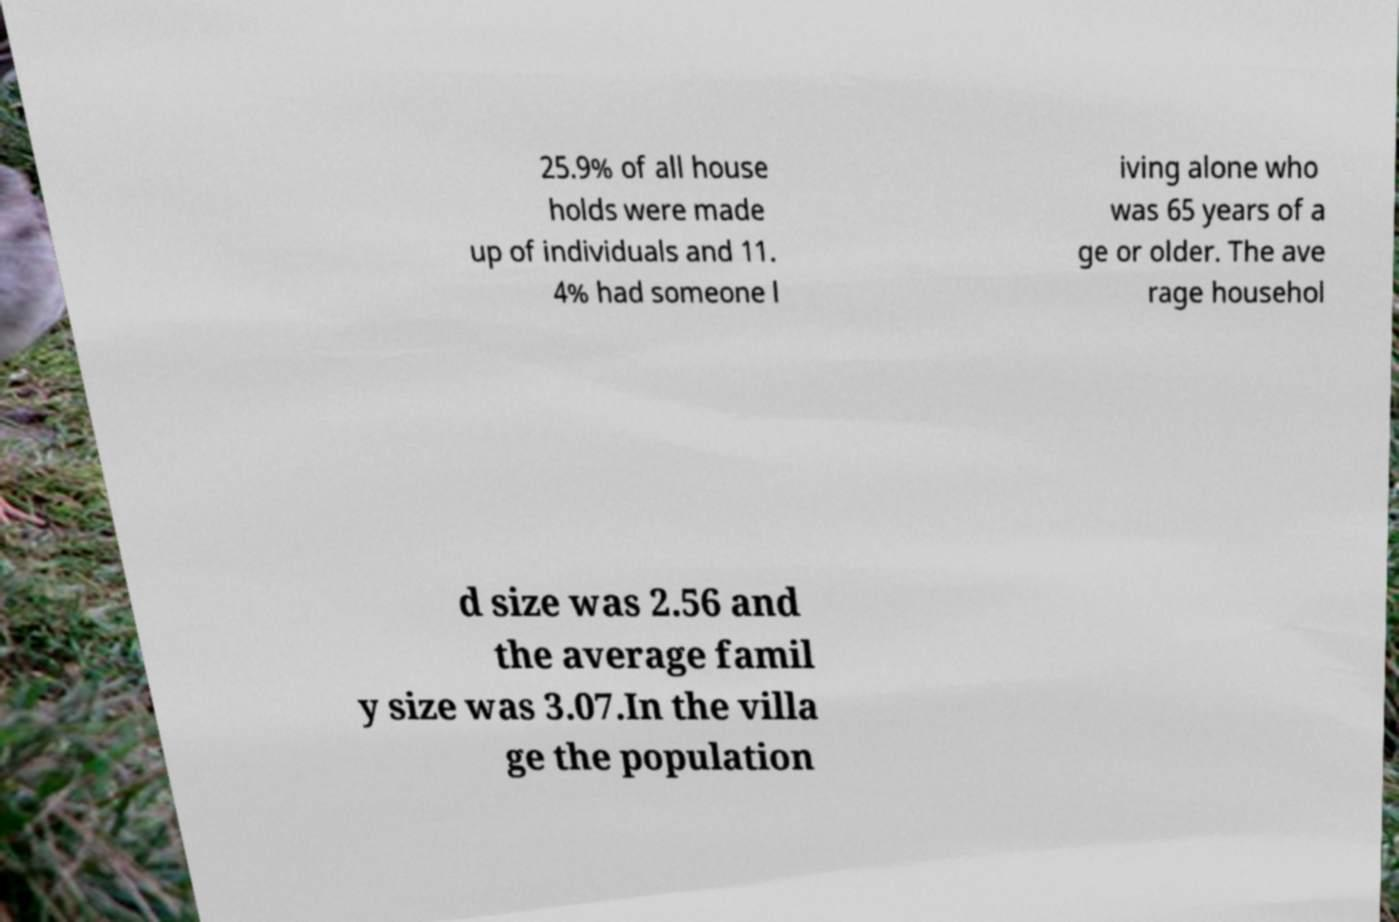Can you read and provide the text displayed in the image?This photo seems to have some interesting text. Can you extract and type it out for me? 25.9% of all house holds were made up of individuals and 11. 4% had someone l iving alone who was 65 years of a ge or older. The ave rage househol d size was 2.56 and the average famil y size was 3.07.In the villa ge the population 